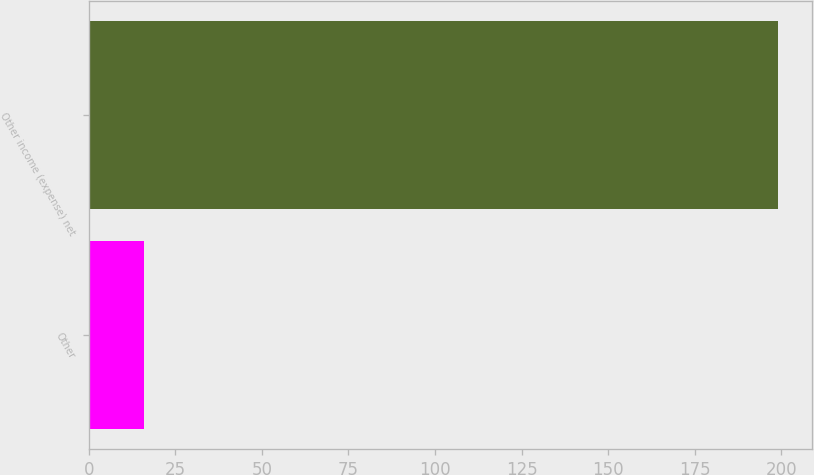Convert chart to OTSL. <chart><loc_0><loc_0><loc_500><loc_500><bar_chart><fcel>Other<fcel>Other income (expense) net<nl><fcel>16<fcel>199<nl></chart> 